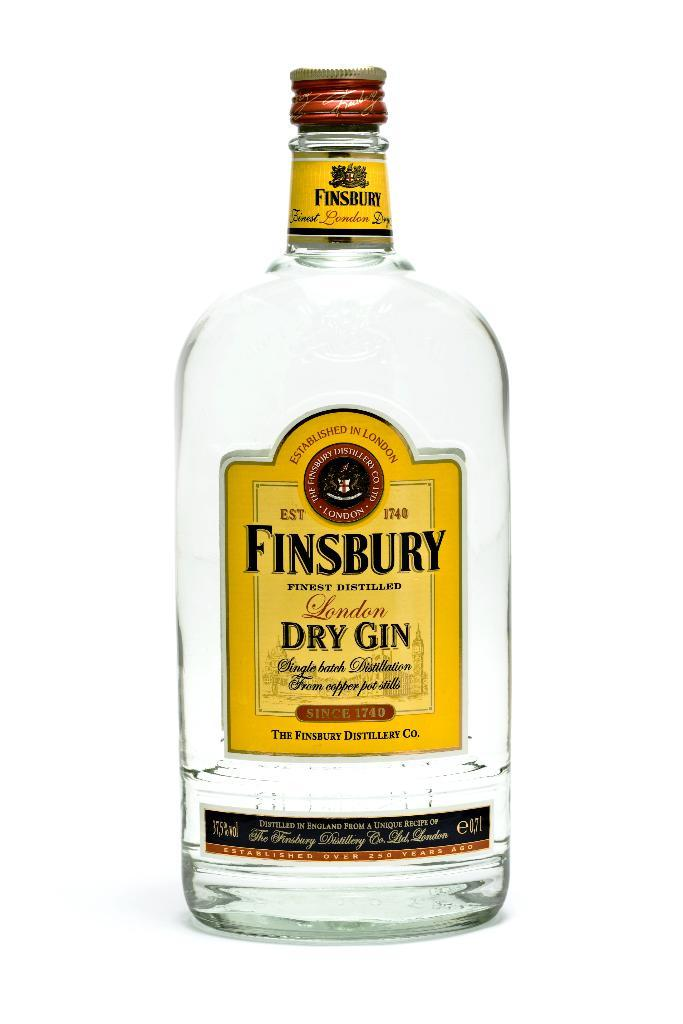<image>
Give a short and clear explanation of the subsequent image. Large clear bottle of Finsbury Dry Gin made in London by the Finsbury Distillery Co. 